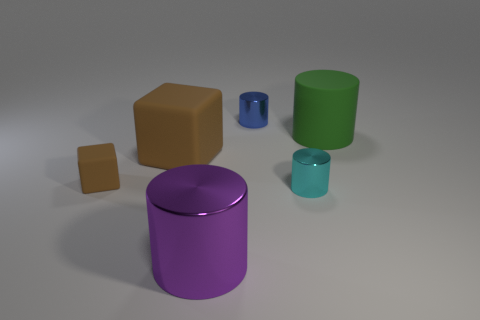Add 1 big matte blocks. How many objects exist? 7 Subtract all blocks. How many objects are left? 4 Subtract 1 cyan cylinders. How many objects are left? 5 Subtract all cyan objects. Subtract all purple metal objects. How many objects are left? 4 Add 5 small rubber blocks. How many small rubber blocks are left? 6 Add 3 big purple metallic objects. How many big purple metallic objects exist? 4 